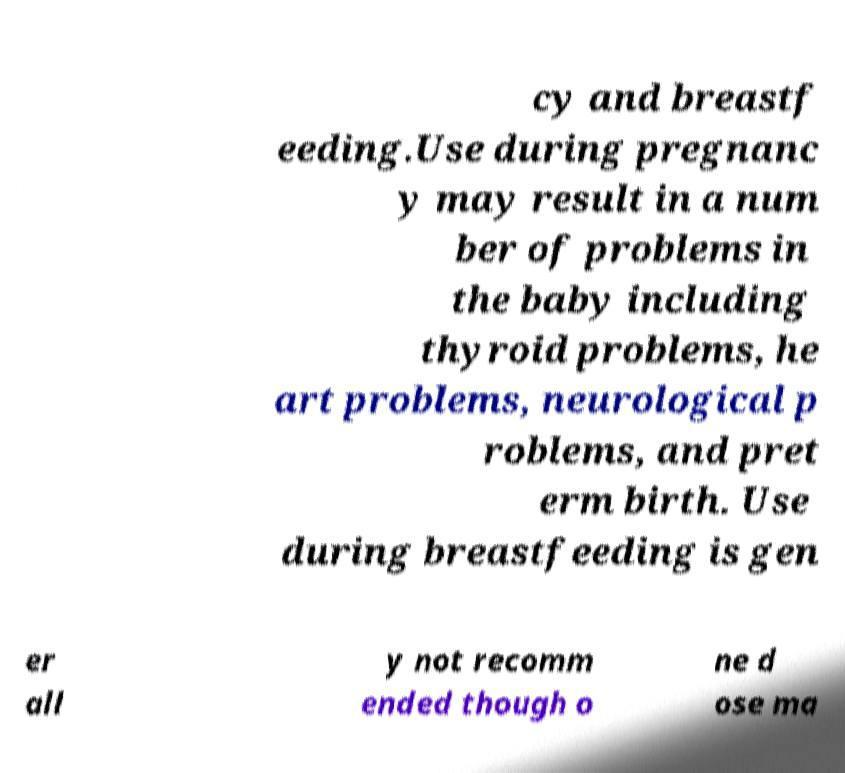Could you assist in decoding the text presented in this image and type it out clearly? cy and breastf eeding.Use during pregnanc y may result in a num ber of problems in the baby including thyroid problems, he art problems, neurological p roblems, and pret erm birth. Use during breastfeeding is gen er all y not recomm ended though o ne d ose ma 